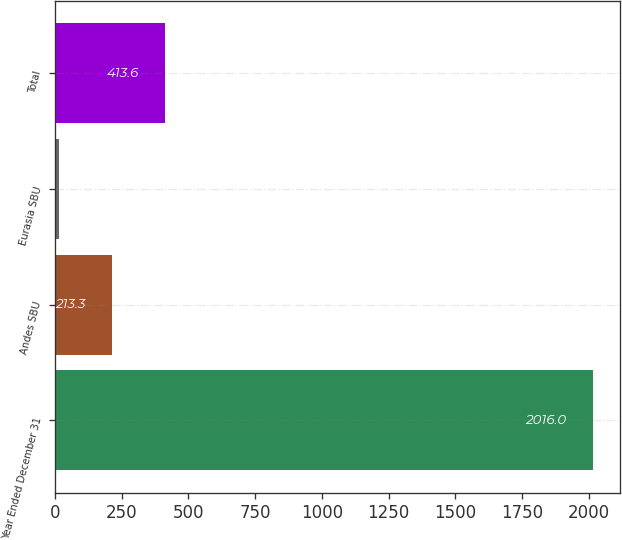<chart> <loc_0><loc_0><loc_500><loc_500><bar_chart><fcel>Year Ended December 31<fcel>Andes SBU<fcel>Eurasia SBU<fcel>Total<nl><fcel>2016<fcel>213.3<fcel>13<fcel>413.6<nl></chart> 